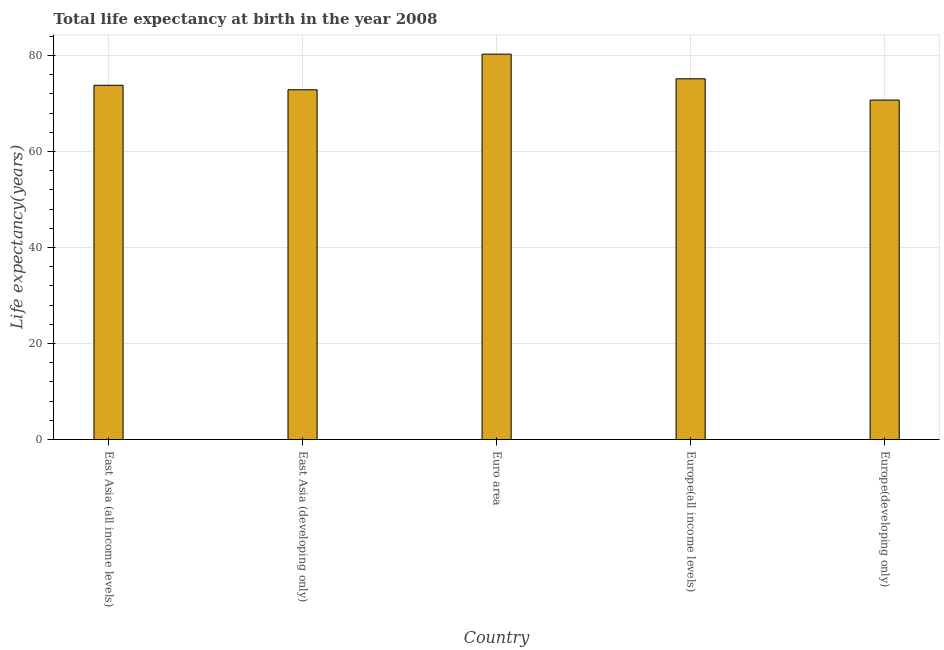What is the title of the graph?
Offer a very short reply. Total life expectancy at birth in the year 2008. What is the label or title of the X-axis?
Provide a succinct answer. Country. What is the label or title of the Y-axis?
Provide a succinct answer. Life expectancy(years). What is the life expectancy at birth in East Asia (all income levels)?
Provide a succinct answer. 73.81. Across all countries, what is the maximum life expectancy at birth?
Keep it short and to the point. 80.3. Across all countries, what is the minimum life expectancy at birth?
Offer a terse response. 70.73. In which country was the life expectancy at birth minimum?
Your answer should be very brief. Europe(developing only). What is the sum of the life expectancy at birth?
Your response must be concise. 372.89. What is the difference between the life expectancy at birth in East Asia (all income levels) and Europe(developing only)?
Offer a terse response. 3.08. What is the average life expectancy at birth per country?
Provide a succinct answer. 74.58. What is the median life expectancy at birth?
Offer a terse response. 73.81. What is the ratio of the life expectancy at birth in Euro area to that in Europe(developing only)?
Offer a terse response. 1.14. Is the life expectancy at birth in Europe(all income levels) less than that in Europe(developing only)?
Ensure brevity in your answer.  No. Is the difference between the life expectancy at birth in Euro area and Europe(all income levels) greater than the difference between any two countries?
Your answer should be compact. No. What is the difference between the highest and the second highest life expectancy at birth?
Provide a short and direct response. 5.14. What is the difference between the highest and the lowest life expectancy at birth?
Give a very brief answer. 9.57. In how many countries, is the life expectancy at birth greater than the average life expectancy at birth taken over all countries?
Offer a very short reply. 2. How many bars are there?
Your answer should be compact. 5. Are all the bars in the graph horizontal?
Give a very brief answer. No. How many countries are there in the graph?
Your answer should be very brief. 5. Are the values on the major ticks of Y-axis written in scientific E-notation?
Offer a very short reply. No. What is the Life expectancy(years) of East Asia (all income levels)?
Offer a very short reply. 73.81. What is the Life expectancy(years) in East Asia (developing only)?
Your response must be concise. 72.87. What is the Life expectancy(years) in Euro area?
Make the answer very short. 80.3. What is the Life expectancy(years) in Europe(all income levels)?
Your response must be concise. 75.17. What is the Life expectancy(years) of Europe(developing only)?
Provide a short and direct response. 70.73. What is the difference between the Life expectancy(years) in East Asia (all income levels) and East Asia (developing only)?
Provide a short and direct response. 0.94. What is the difference between the Life expectancy(years) in East Asia (all income levels) and Euro area?
Provide a short and direct response. -6.49. What is the difference between the Life expectancy(years) in East Asia (all income levels) and Europe(all income levels)?
Offer a very short reply. -1.35. What is the difference between the Life expectancy(years) in East Asia (all income levels) and Europe(developing only)?
Provide a short and direct response. 3.08. What is the difference between the Life expectancy(years) in East Asia (developing only) and Euro area?
Make the answer very short. -7.43. What is the difference between the Life expectancy(years) in East Asia (developing only) and Europe(all income levels)?
Your answer should be compact. -2.29. What is the difference between the Life expectancy(years) in East Asia (developing only) and Europe(developing only)?
Provide a succinct answer. 2.14. What is the difference between the Life expectancy(years) in Euro area and Europe(all income levels)?
Your answer should be very brief. 5.14. What is the difference between the Life expectancy(years) in Euro area and Europe(developing only)?
Your answer should be compact. 9.57. What is the difference between the Life expectancy(years) in Europe(all income levels) and Europe(developing only)?
Keep it short and to the point. 4.43. What is the ratio of the Life expectancy(years) in East Asia (all income levels) to that in East Asia (developing only)?
Offer a terse response. 1.01. What is the ratio of the Life expectancy(years) in East Asia (all income levels) to that in Euro area?
Your answer should be very brief. 0.92. What is the ratio of the Life expectancy(years) in East Asia (all income levels) to that in Europe(all income levels)?
Your answer should be very brief. 0.98. What is the ratio of the Life expectancy(years) in East Asia (all income levels) to that in Europe(developing only)?
Provide a succinct answer. 1.04. What is the ratio of the Life expectancy(years) in East Asia (developing only) to that in Euro area?
Your answer should be very brief. 0.91. What is the ratio of the Life expectancy(years) in East Asia (developing only) to that in Europe(all income levels)?
Make the answer very short. 0.97. What is the ratio of the Life expectancy(years) in Euro area to that in Europe(all income levels)?
Your response must be concise. 1.07. What is the ratio of the Life expectancy(years) in Euro area to that in Europe(developing only)?
Keep it short and to the point. 1.14. What is the ratio of the Life expectancy(years) in Europe(all income levels) to that in Europe(developing only)?
Your answer should be compact. 1.06. 